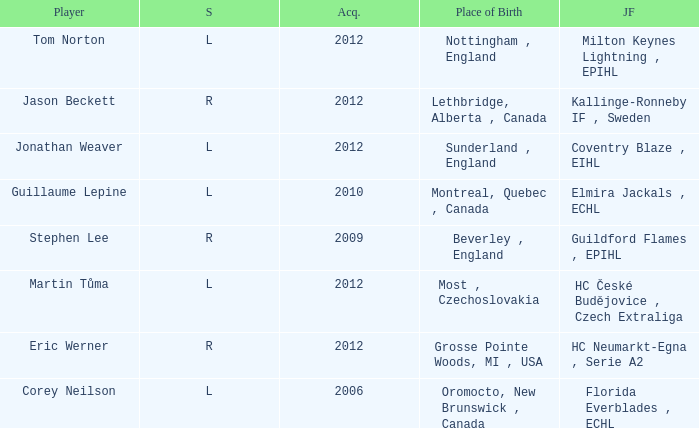Who acquired tom norton? 2012.0. 